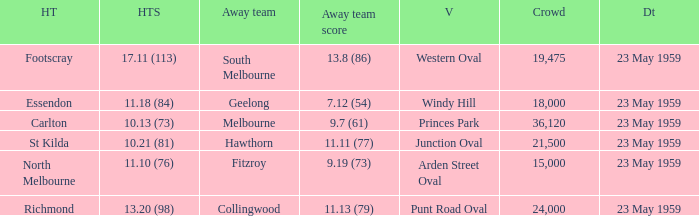What was the home team's score at the game held at Punt Road Oval? 13.20 (98). 